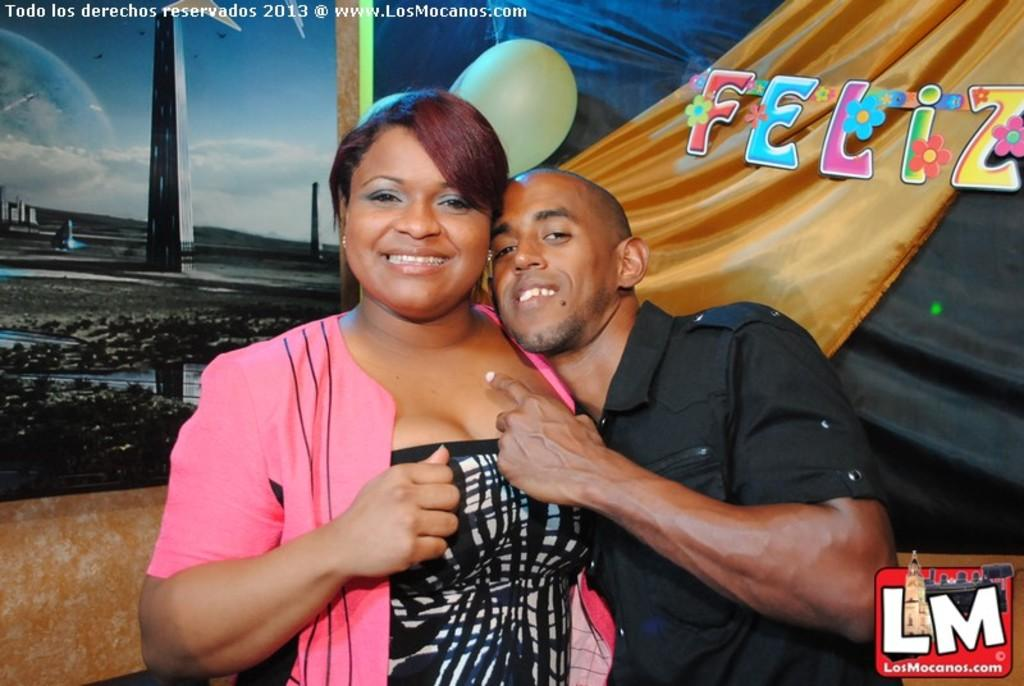How many people are in the image? There are two people in the image, a woman and a man. What are the people in the image doing? Both the woman and the man are standing and smiling. What can be seen in the background of the image? There is a banner in the background of the image. Where is the logo located in the image? The logo is at the right side bottom of the image. What type of yarn is the woman wearing in the image? There is no yarn visible in the image; the woman is not wearing any apparel made of yarn. What competition are the woman and the man participating in, as seen in the image? There is no indication of a competition in the image; it simply shows a woman and a man standing and smiling. 